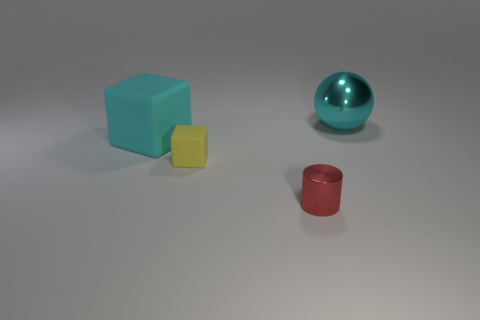How many other objects are the same color as the large block?
Provide a succinct answer. 1. What number of tiny red metallic things are there?
Your answer should be very brief. 1. Is the number of tiny red objects that are behind the small yellow object less than the number of big matte cubes?
Your answer should be very brief. Yes. Is the cyan thing to the right of the yellow rubber block made of the same material as the yellow block?
Your response must be concise. No. What is the shape of the cyan object that is behind the large object left of the big object on the right side of the yellow thing?
Provide a short and direct response. Sphere. Are there any cyan rubber things of the same size as the yellow matte cube?
Provide a succinct answer. No. The cyan ball has what size?
Offer a very short reply. Large. What number of other cyan metallic balls are the same size as the cyan metal ball?
Offer a very short reply. 0. Are there fewer big spheres that are on the left side of the big cyan cube than yellow things to the left of the yellow cube?
Offer a terse response. No. What size is the block that is on the right side of the cyan thing left of the metal object that is in front of the cyan ball?
Ensure brevity in your answer.  Small. 